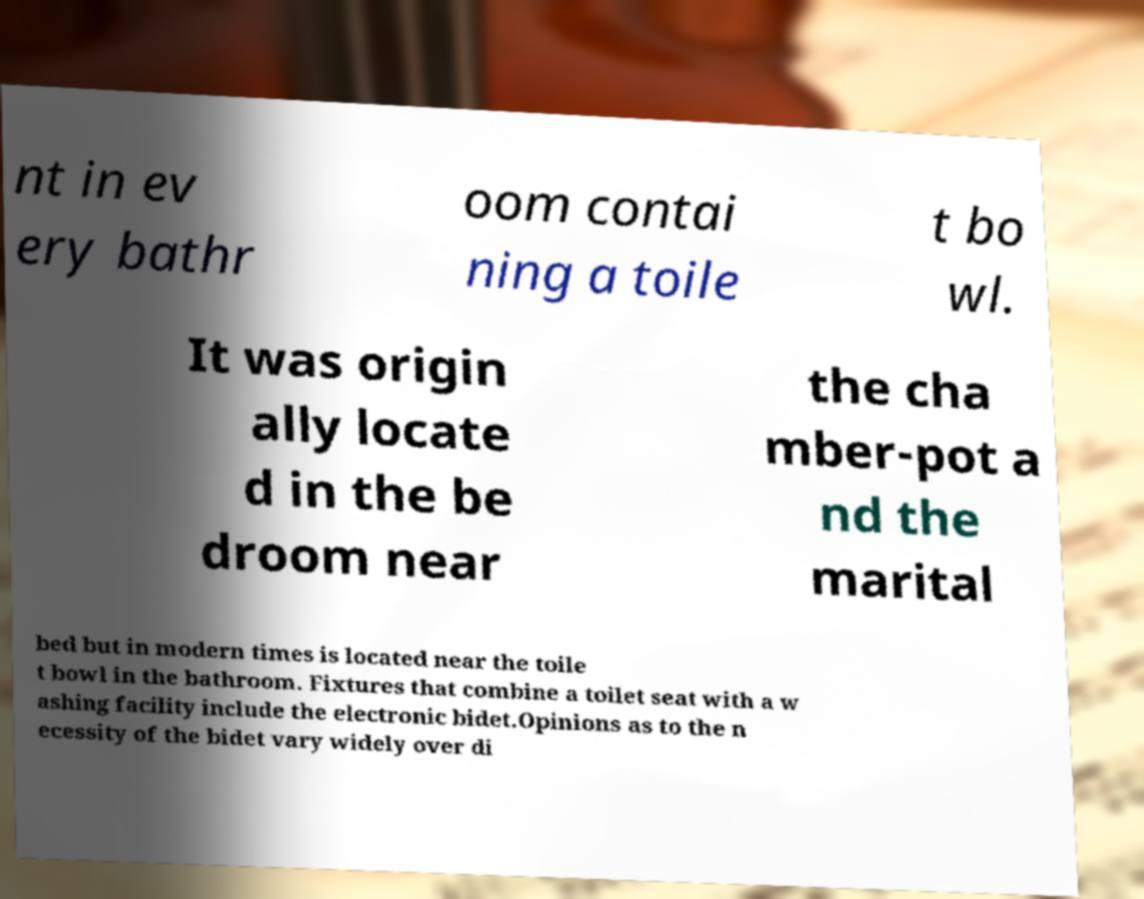Could you assist in decoding the text presented in this image and type it out clearly? nt in ev ery bathr oom contai ning a toile t bo wl. It was origin ally locate d in the be droom near the cha mber-pot a nd the marital bed but in modern times is located near the toile t bowl in the bathroom. Fixtures that combine a toilet seat with a w ashing facility include the electronic bidet.Opinions as to the n ecessity of the bidet vary widely over di 